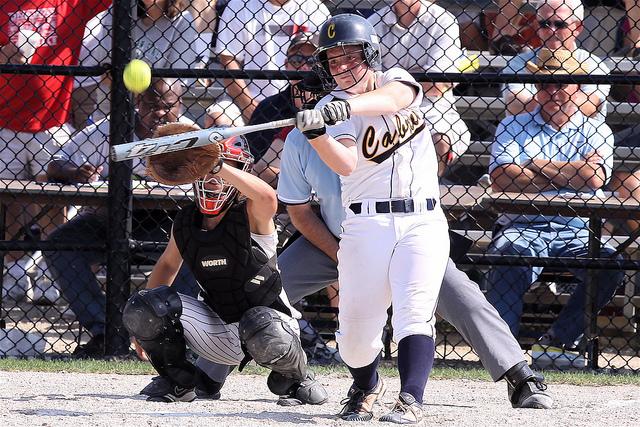What sport is this?
Short answer required. Baseball. What position does the player with the glove play?
Answer briefly. Catcher. Did he hit that ball?
Concise answer only. Yes. 